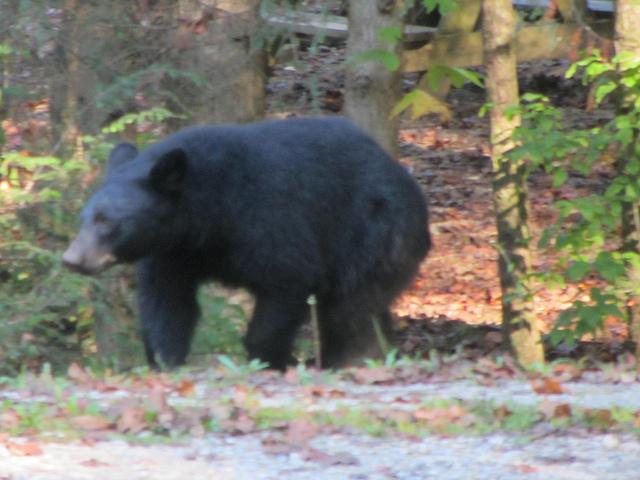What is all over the ground?
Concise answer only. Leaves. Is the bear facing the right?
Concise answer only. No. Where is the bear coming out from?
Quick response, please. Woods. Is there a bear cub?
Concise answer only. No. 